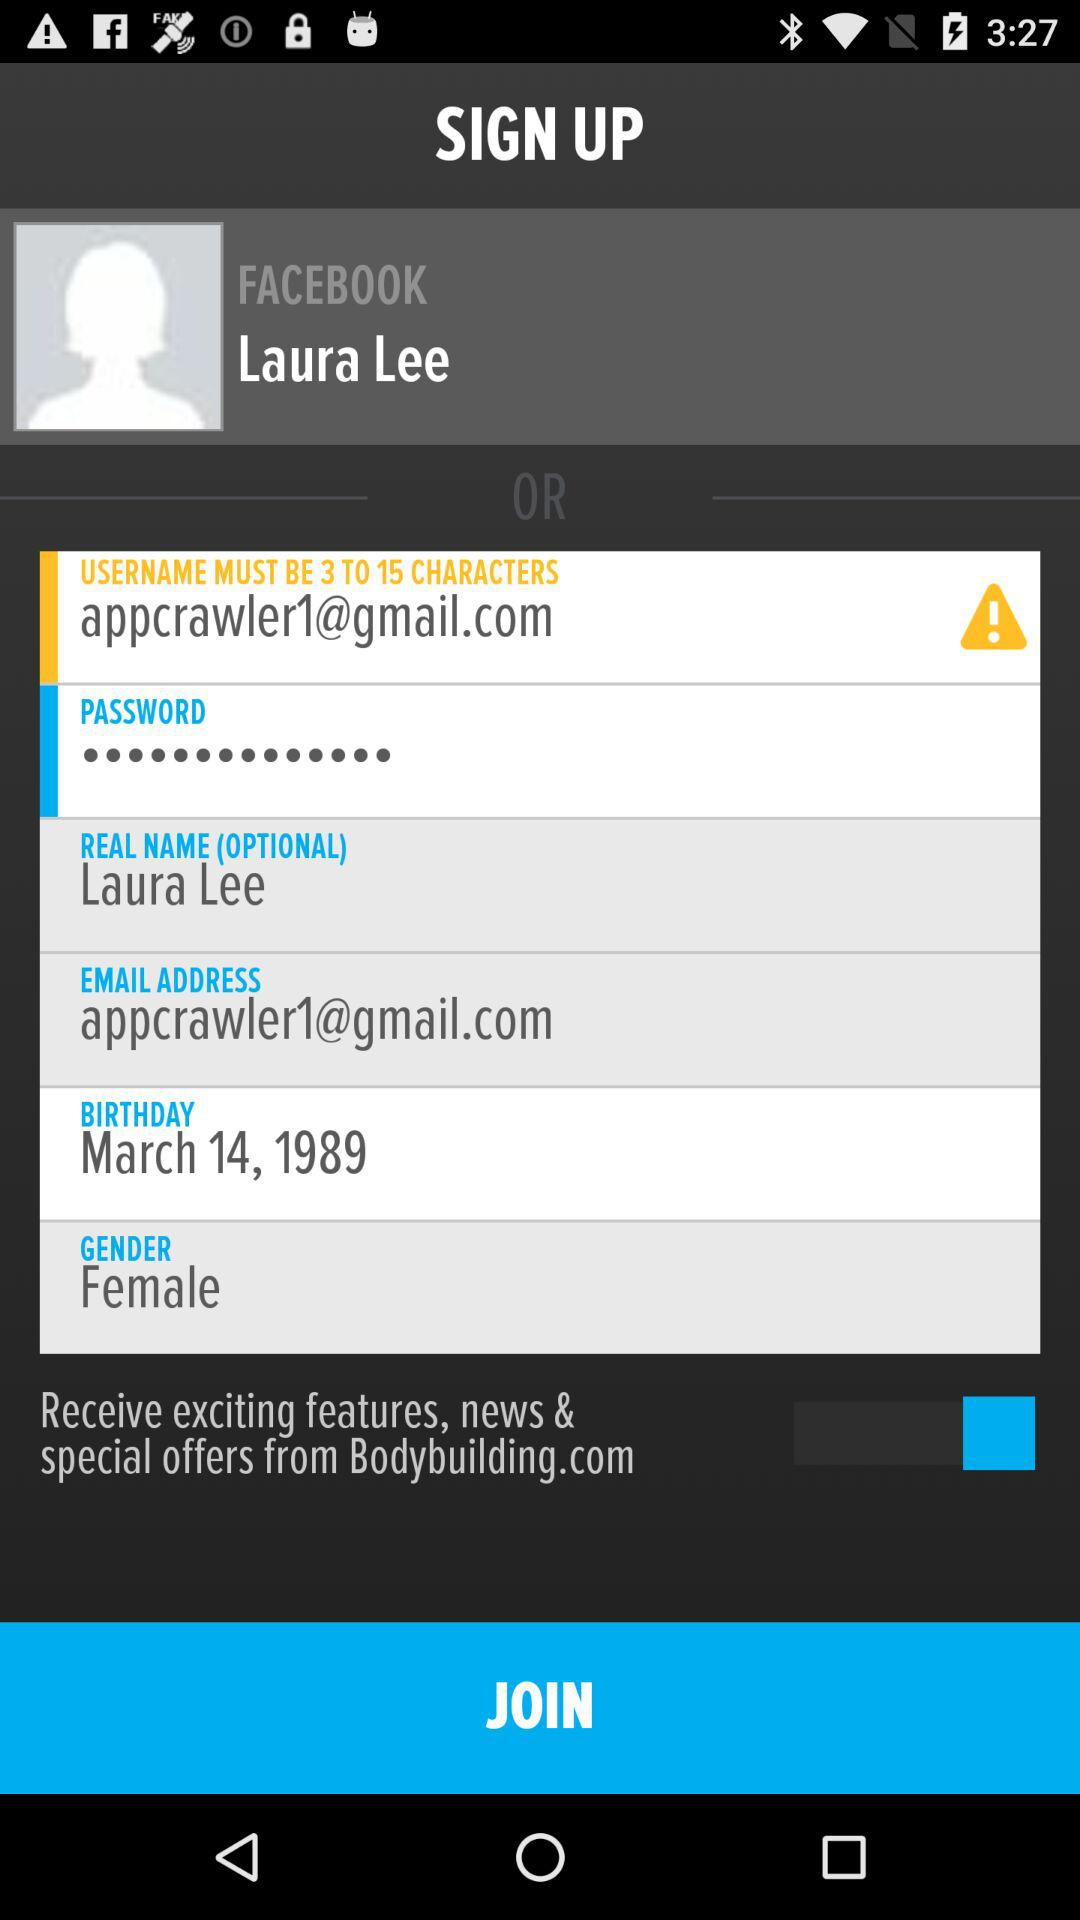What's the birthdate? The birthdate is March 14, 1989. 